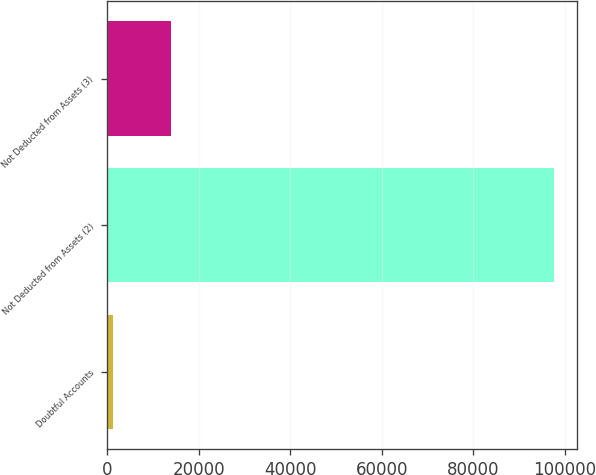Convert chart. <chart><loc_0><loc_0><loc_500><loc_500><bar_chart><fcel>Doubtful Accounts<fcel>Not Deducted from Assets (2)<fcel>Not Deducted from Assets (3)<nl><fcel>1306<fcel>97680<fcel>13896<nl></chart> 